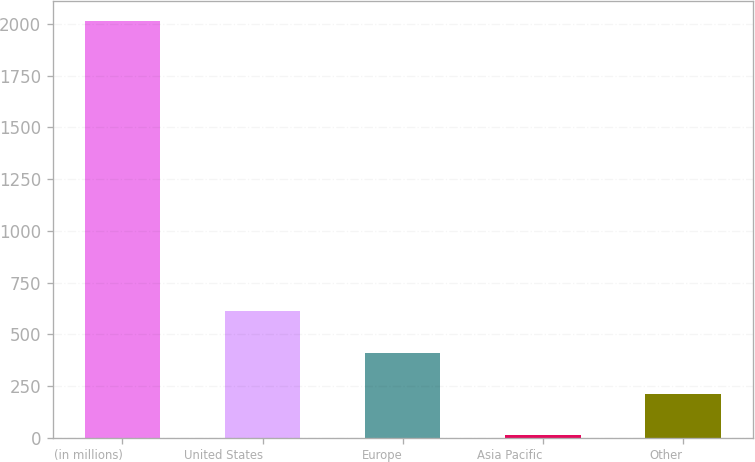Convert chart. <chart><loc_0><loc_0><loc_500><loc_500><bar_chart><fcel>(in millions)<fcel>United States<fcel>Europe<fcel>Asia Pacific<fcel>Other<nl><fcel>2012<fcel>612<fcel>412<fcel>12<fcel>212<nl></chart> 